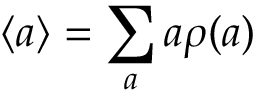Convert formula to latex. <formula><loc_0><loc_0><loc_500><loc_500>\langle a \rangle = \sum _ { a } a \rho ( a )</formula> 